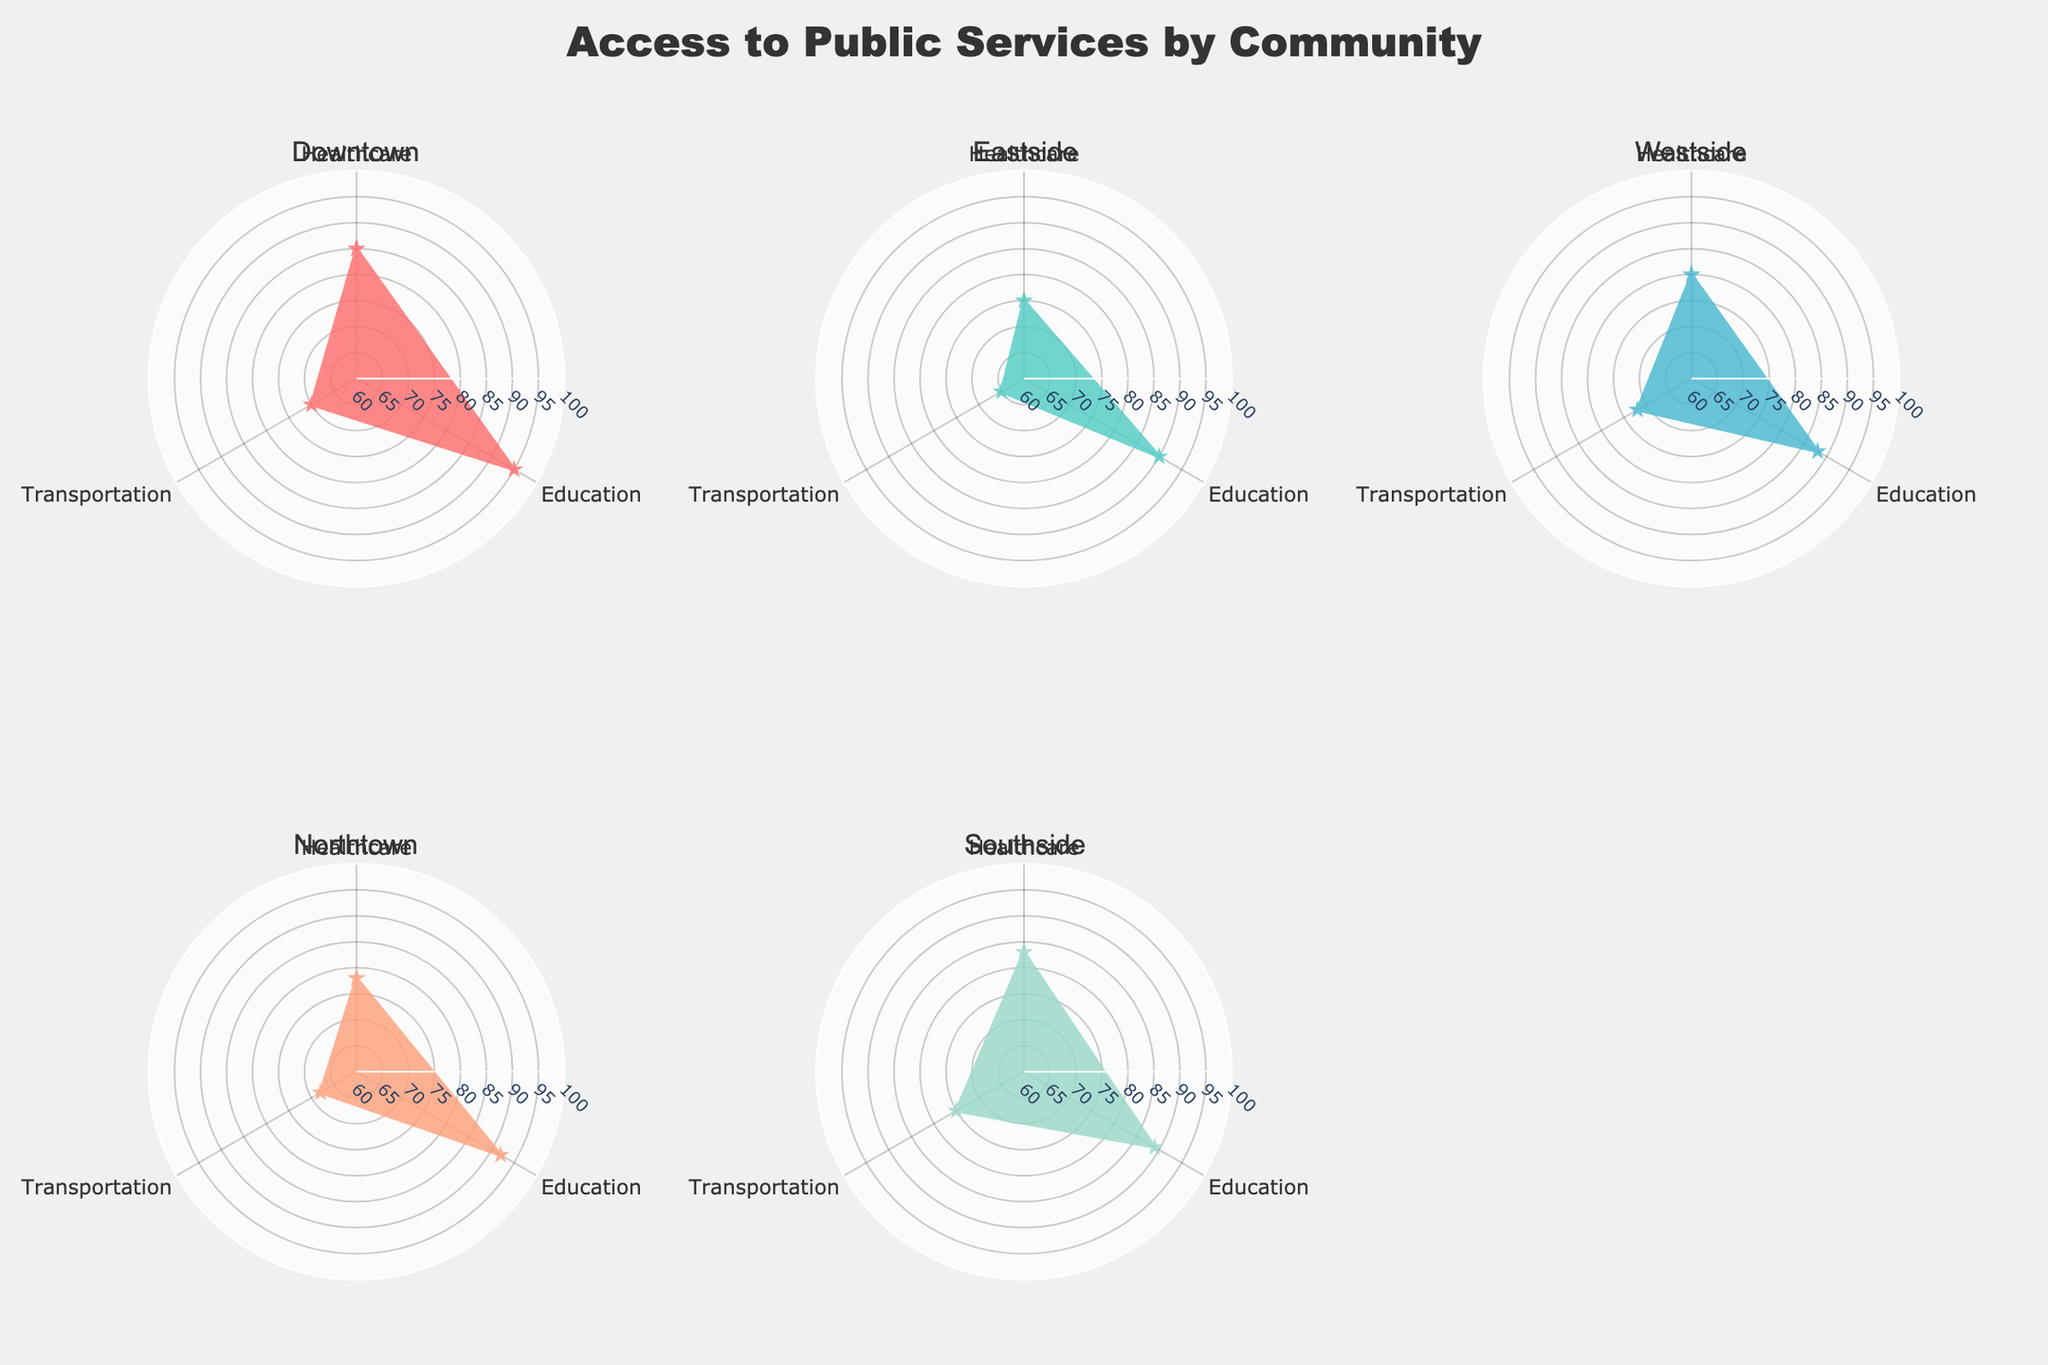Which community has the highest percentage of members using healthcare services? To find the community with the highest percentage for healthcare services, we need to look at the visual representation of the data in the radar chart. By observing the values, Downtown has the highest percentage at 85%.
Answer: Downtown What is the average percentage of community members using public transportation across all communities? First, we find the transportation values for each community: 70, 65, 72, 68, 75. Sum these values (70 + 65 + 72 + 68 + 75 = 350) and then divide by the number of communities (350 / 5 = 70).
Answer: 70 Which community has the lowest percentage of members using educational services? By observing the radar chart for education, Westside has the lowest usage percentage at 88%.
Answer: Westside Compare Downtown and Eastside communities: which one has better access to transportation services? To compare transportation services, we look at the respective values in the radar chart. Downtown has 70 and Eastside has 65. Since 70 is greater than 65, Downtown has better access.
Answer: Downtown Rank the communities in descending order of healthcare service usage. We need to refer to the healthcare percentage for each community: Downtown (85), Eastside (75), Westside (80), Northtown (78), Southside (83). Sorting these values in descending order gives us Downtown (85), Southside (83), Westside (80), Northtown (78), Eastside (75).
Answer: Downtown, Southside, Westside, Northtown, Eastside What is the combined percentage of healthcare and education services in the Southside community? For Southside, the healthcare percentage is 83 and education is 89. Adding these together gives 83 + 89 = 172.
Answer: 172 Identify any community with equal access to multiple services. By observing the radar chart, none of the communities have equal percentages for different services; each has distinct values for healthcare, education, and transportation.
Answer: None Among all the communities, which one has the most balanced access to healthcare, education, and transportation? A balanced access means percentages are close to each other. By assessing all radar charts, Westside shows somewhat balanced access with percentages of 80 (healthcare), 88 (education), and 72 (transportation).
Answer: Westside 